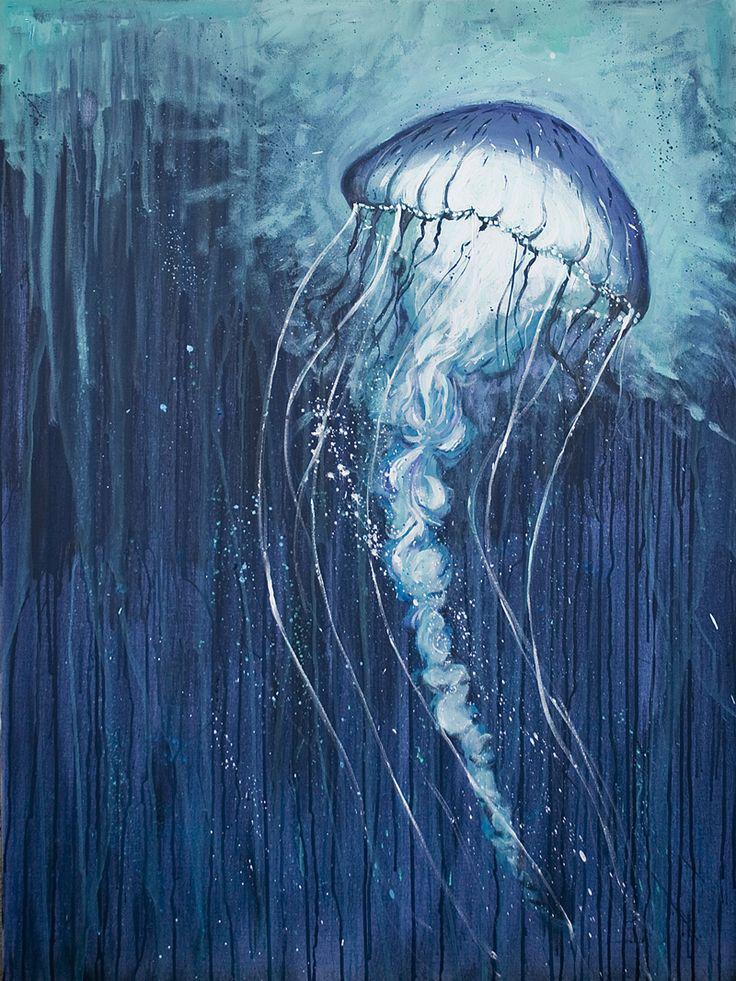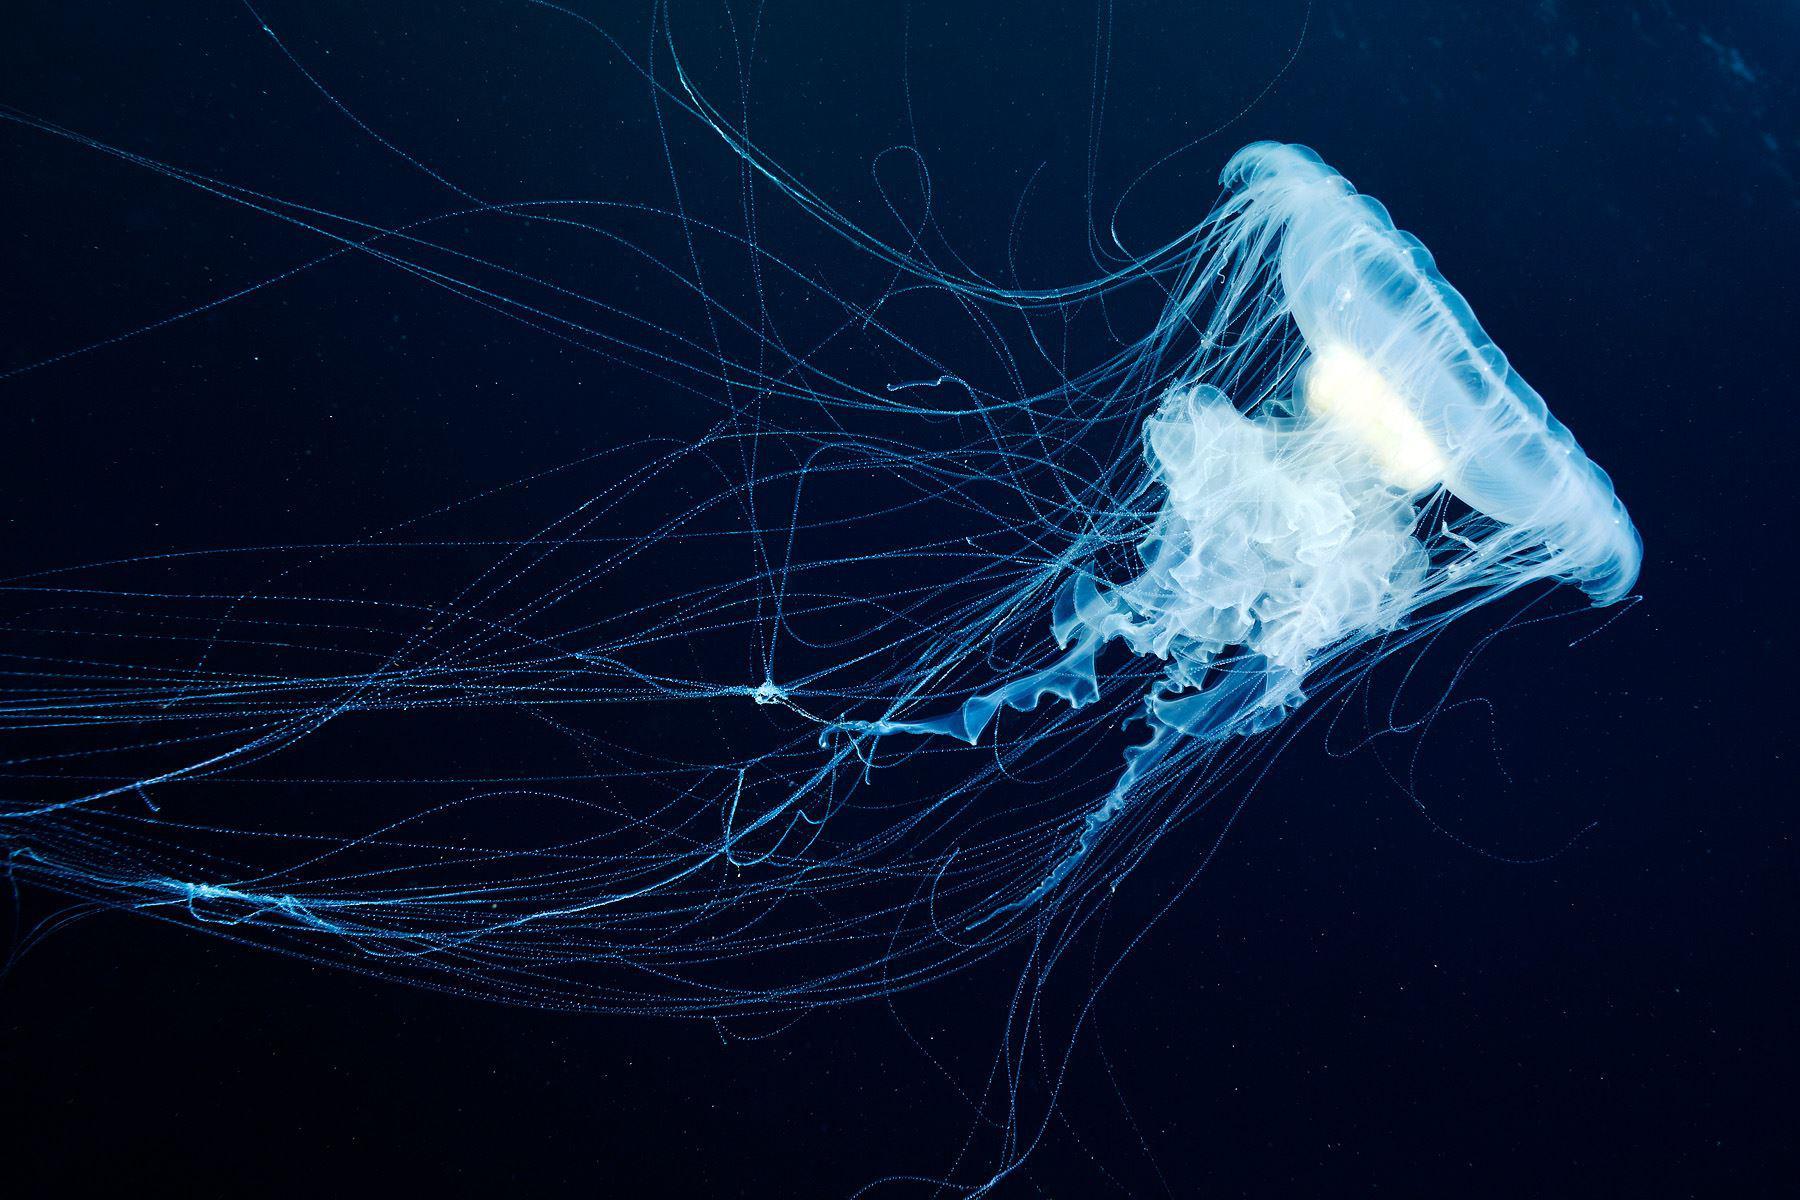The first image is the image on the left, the second image is the image on the right. Evaluate the accuracy of this statement regarding the images: "Each image shows a translucent bluish-white jellyfish shaped like a mushroom, with threadlike and ruffly tentacles trailing under it.". Is it true? Answer yes or no. Yes. 